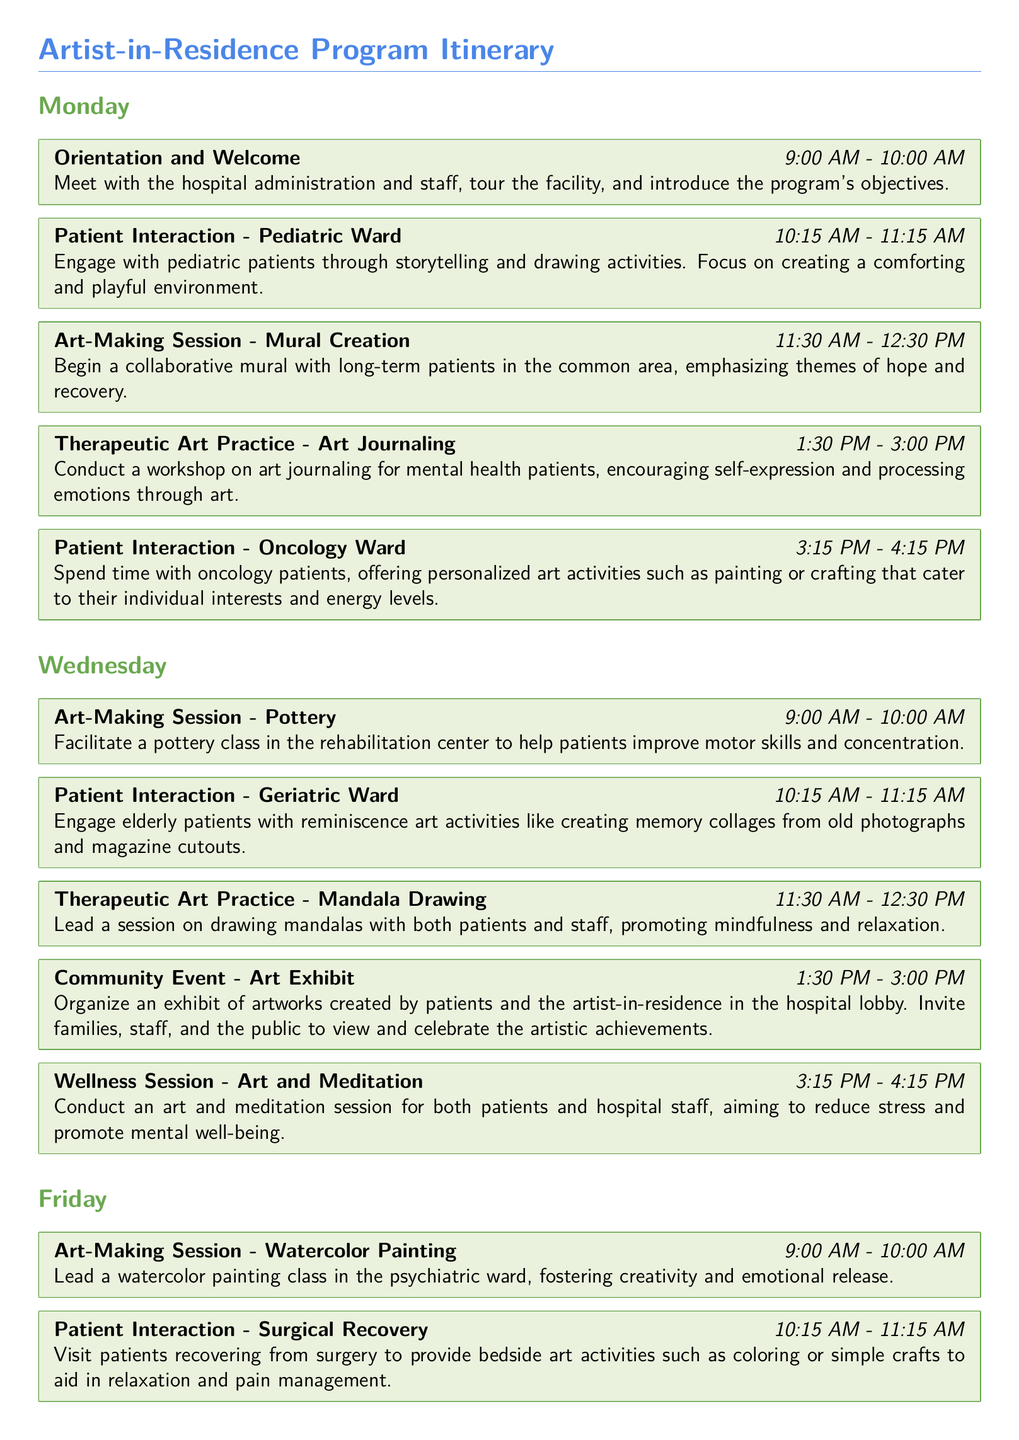What is the first activity on Monday? The first activity on Monday is the orientation and welcome session scheduled from 9:00 AM to 10:00 AM.
Answer: Orientation and Welcome Which ward is engaged in the artistic activities on Wednesday at 10:15 AM? The artistic activities on Wednesday at 10:15 AM are focused on the geriatric ward.
Answer: Geriatric Ward What therapeutic art practice is scheduled for Monday at 1:30 PM? The therapeutic art practice scheduled for Monday at 1:30 PM is art journaling.
Answer: Art Journaling How many total sessions are scheduled for Friday? There are a total of five sessions scheduled for Friday, including both art-making and wellness sessions.
Answer: 5 What theme is emphasized in the mural creation on Monday? The theme emphasized in the mural creation on Monday is hope and recovery.
Answer: Hope and recovery What is the time for the community event on Wednesday? The community event on Wednesday is scheduled from 1:30 PM to 3:00 PM.
Answer: 1:30 PM - 3:00 PM What type of session is held at 3:15 PM on Wednesday? The session held at 3:15 PM on Wednesday is an art and meditation session.
Answer: Art and Meditation How long is each patient interaction session typically? Each patient interaction session is typically one hour long.
Answer: One hour 